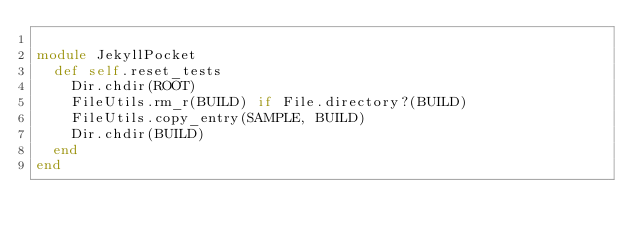Convert code to text. <code><loc_0><loc_0><loc_500><loc_500><_Ruby_>
module JekyllPocket
  def self.reset_tests
    Dir.chdir(ROOT)
    FileUtils.rm_r(BUILD) if File.directory?(BUILD)
    FileUtils.copy_entry(SAMPLE, BUILD)
    Dir.chdir(BUILD)
  end
end
</code> 